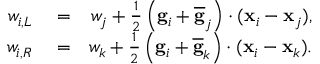Convert formula to latex. <formula><loc_0><loc_0><loc_500><loc_500>\begin{array} { r l r } { w _ { i , L } } & = } & { w _ { j } + \frac { 1 } { 2 } \left ( { g } _ { i } + \overline { g } _ { j } \right ) \cdot ( { x } _ { i } - { x } _ { j } ) , } \\ { w _ { i , R } } & = } & { w _ { k } + \frac { 1 } { 2 } \left ( { g } _ { i } + \overline { g } _ { k } \right ) \cdot ( { x } _ { i } - { x } _ { k } ) . } \end{array}</formula> 